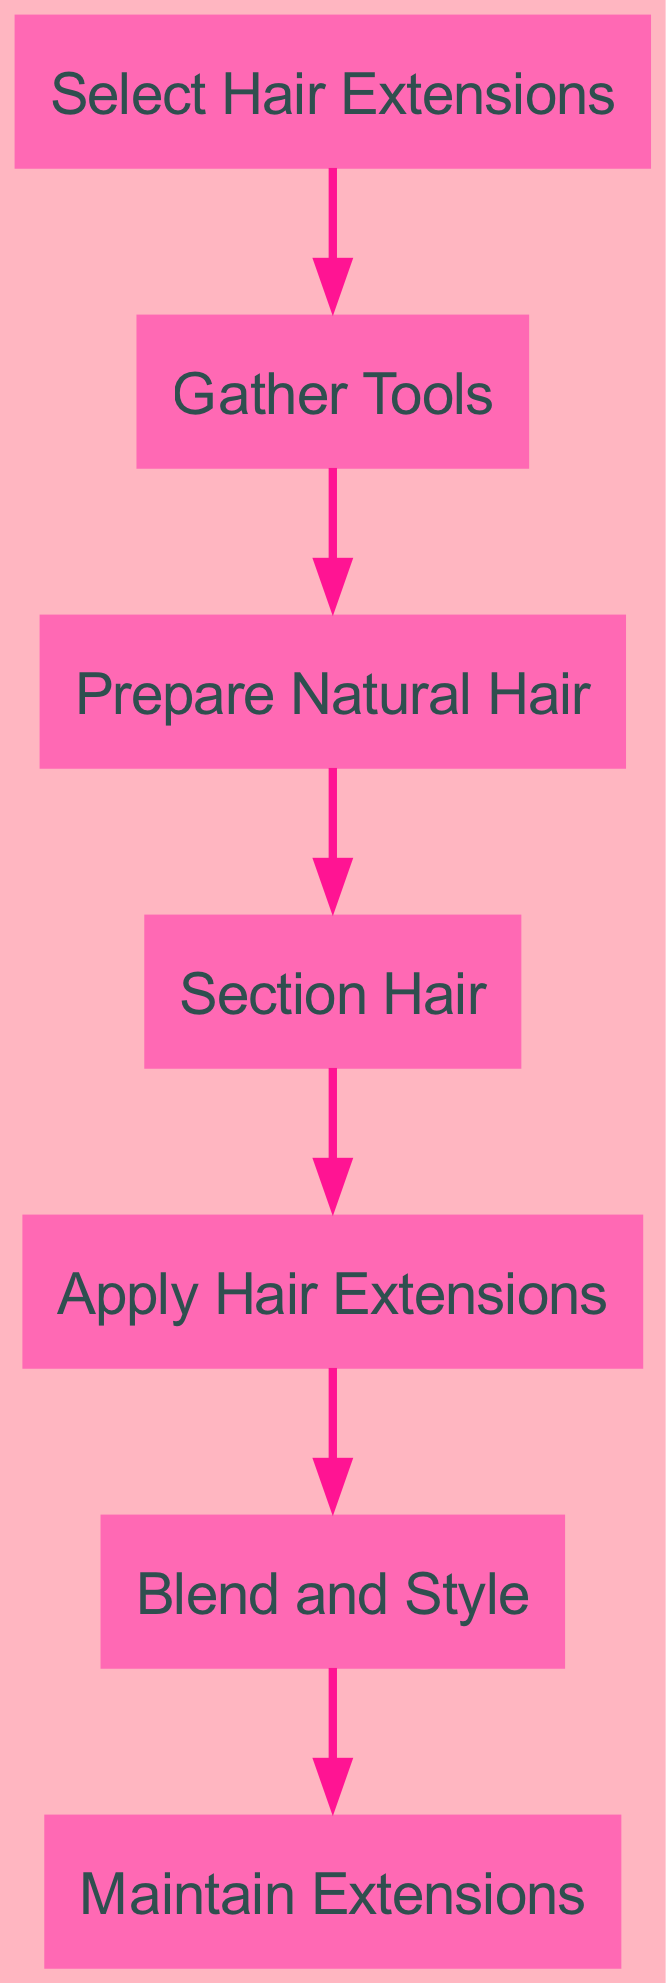What is the first step in the hair extension application process? The first step is identified by the node labeled "Select Hair Extensions," which comes before all other steps in the flow of the diagram.
Answer: Select Hair Extensions What is the last step in the hair extension application process? The last step is found at the end of the diagram, represented by the node labeled "Maintain Extensions." This node follows after "Blend and Style."
Answer: Maintain Extensions How many total steps are there in the application process? Counting all the nodes in the diagram indicates that there are seven distinct steps, from "Select Hair Extensions" to "Maintain Extensions."
Answer: 7 What is the relationship between "Gather Tools" and "Prepare Natural Hair"? "Gather Tools" directly precedes "Prepare Natural Hair," indicating a sequential relationship where tools are gathered first before preparing natural hair for extensions.
Answer: Sequential Which step comes immediately after "Apply Hair Extensions"? Following "Apply Hair Extensions," the next step in the diagram is "Blend and Style," which directly follows it in the flow.
Answer: Blend and Style What step must be completed before applying hair extensions? The step that must be completed prior to applying hair extensions is "Section Hair," as indicated by the directed flow from the "Section Hair" node to the "Apply Hair Extensions" node.
Answer: Section Hair How many edges are in the diagram? The diagram shows six edges that connect the nodes, which represent the transitions from one step to the next in the hair extension application process.
Answer: 6 Which two nodes are directly connected to the "Blend and Style" node? The nodes "Apply Hair Extensions" and "Maintain Extensions" are directly connected to "Blend and Style," indicating the steps that come before and after it, respectively.
Answer: Apply Hair Extensions, Maintain Extensions Is "Prepare Natural Hair" the starting point of the process? No, "Prepare Natural Hair" is not the starting point; it follows "Gather Tools," making "Select Hair Extensions" the true starting point of the process.
Answer: No What action comes after gathering tools in the process? The action that follows "Gather Tools" is "Prepare Natural Hair," which indicates the next step after tools have been collected.
Answer: Prepare Natural Hair 